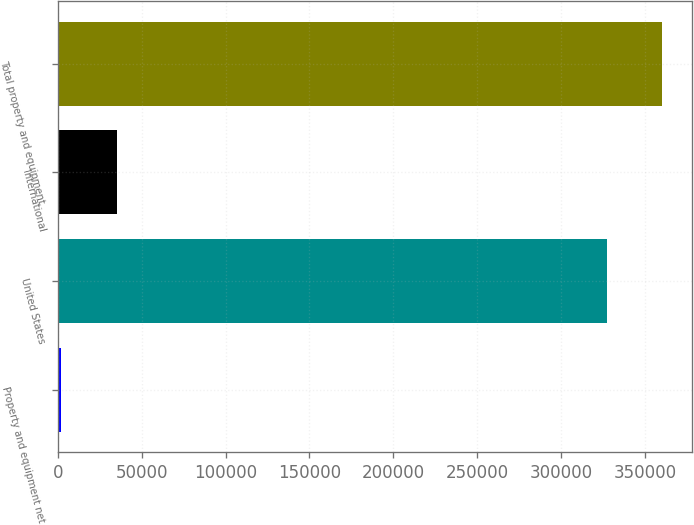<chart> <loc_0><loc_0><loc_500><loc_500><bar_chart><fcel>Property and equipment net<fcel>United States<fcel>International<fcel>Total property and equipment<nl><fcel>2013<fcel>327250<fcel>35077.9<fcel>360315<nl></chart> 